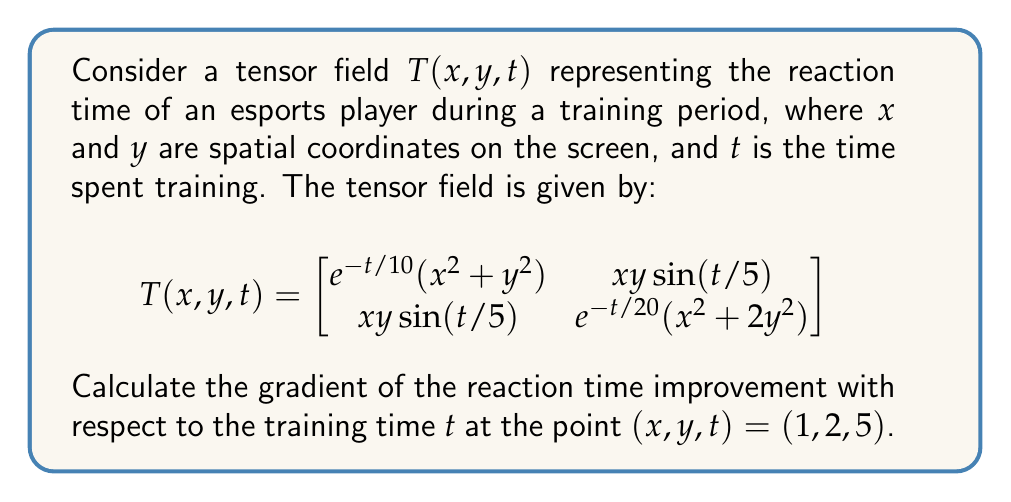Can you solve this math problem? To solve this problem, we need to follow these steps:

1) The gradient of a tensor field with respect to a scalar variable is obtained by taking the partial derivative of each component with respect to that variable.

2) In this case, we need to calculate $\frac{\partial T}{\partial t}$ at the point (1, 2, 5).

3) Let's calculate the partial derivatives for each component:

   For $T_{11} = e^{-t/10}(x^2 + y^2)$:
   $$\frac{\partial T_{11}}{\partial t} = -\frac{1}{10}e^{-t/10}(x^2 + y^2)$$

   For $T_{12} = T_{21} = xy\sin(t/5)$:
   $$\frac{\partial T_{12}}{\partial t} = \frac{\partial T_{21}}{\partial t} = \frac{1}{5}xy\cos(t/5)$$

   For $T_{22} = e^{-t/20}(x^2 + 2y^2)$:
   $$\frac{\partial T_{22}}{\partial t} = -\frac{1}{20}e^{-t/20}(x^2 + 2y^2)$$

4) Now, we substitute the values $x = 1$, $y = 2$, and $t = 5$:

   $$\frac{\partial T}{\partial t}\bigg|_{(1,2,5)} = \begin{bmatrix}
   -\frac{1}{10}e^{-1/2}(1^2 + 2^2) & \frac{1}{5}\cdot1\cdot2\cos(1) \\
   \frac{1}{5}\cdot1\cdot2\cos(1) & -\frac{1}{20}e^{-1/4}(1^2 + 2\cdot2^2)
   \end{bmatrix}$$

5) Evaluating the expressions:
   
   $$\frac{\partial T}{\partial t}\bigg|_{(1,2,5)} \approx \begin{bmatrix}
   -0.3033 & 0.1080 \\
   0.1080 & -0.2266
   \end{bmatrix}$$

This gradient tensor represents the rate of change of reaction time with respect to training time at the given point.
Answer: $$\frac{\partial T}{\partial t}\bigg|_{(1,2,5)} \approx \begin{bmatrix}
-0.3033 & 0.1080 \\
0.1080 & -0.2266
\end{bmatrix}$$ 